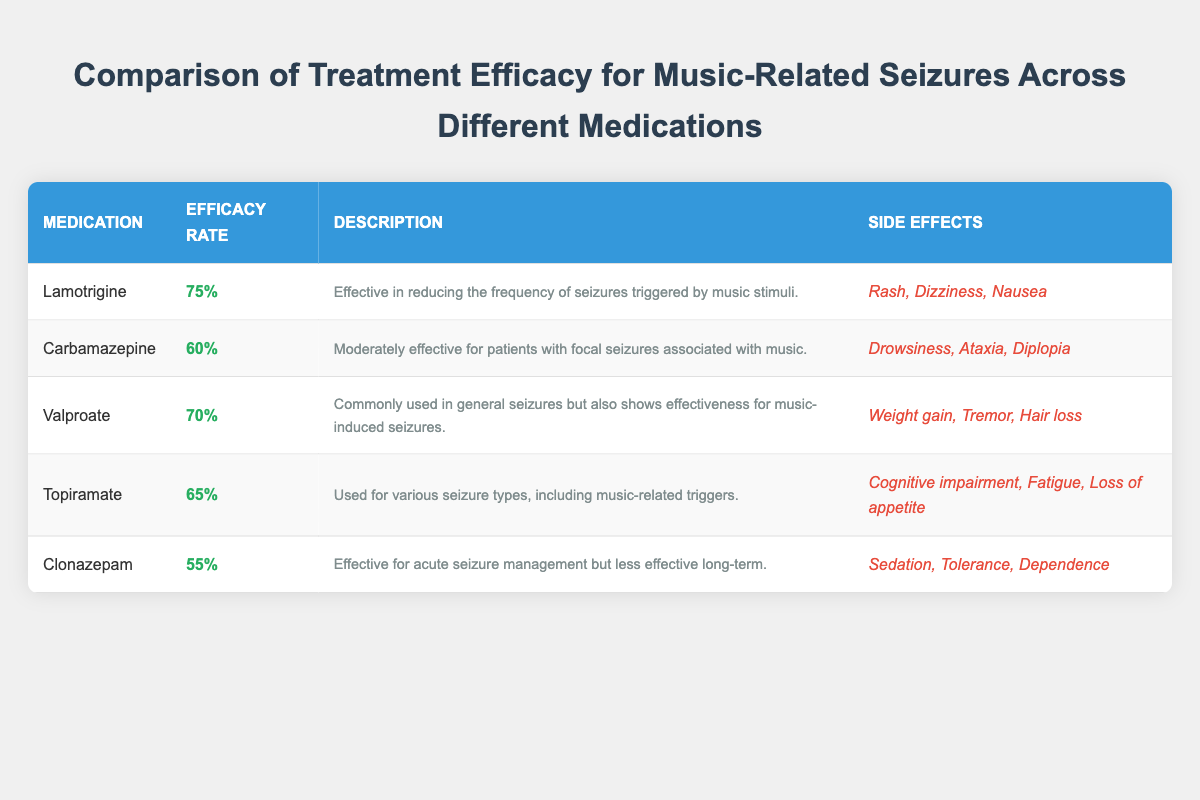What is the efficacy rate of Lamotrigine? The table states that the efficacy rate for Lamotrigine is 75%.
Answer: 75% Which medication has the lowest efficacy rate? By comparing the efficacy rates listed, Clonazepam has the lowest efficacy rate at 55%.
Answer: Clonazepam Is Valproate effective for music-induced seizures? Yes, the table describes Valproate as commonly used in general seizures and effective for music-induced seizures.
Answer: Yes What is the average efficacy rate of the medications listed in the table? First, we sum the efficacy rates: 75 + 60 + 70 + 65 + 55 = 325. There are 5 medications, so we divide: 325 / 5 = 65.
Answer: 65 Does Topiramate have a higher efficacy rate than Clonazepam? Topiramate has an efficacy rate of 65%, while Clonazepam has 55%. Since 65 is greater than 55, Topiramate does have a higher rate.
Answer: Yes What side effects are associated with Carbamazepine? The table lists Drowsiness, Ataxia, and Diplopia as the side effects associated with Carbamazepine.
Answer: Drowsiness, Ataxia, Diplopia Which medication is described as effective in reducing the frequency of seizures triggered by music stimuli? The description for Lamotrigine states it is effective in reducing the frequency of seizures triggered by music stimuli.
Answer: Lamotrigine What is the difference between the highest and lowest efficacy rates? The highest efficacy rate is 75% for Lamotrigine, and the lowest is 55% for Clonazepam. The difference is 75 - 55 = 20.
Answer: 20 Is the side effect profile for Lamotrigine more favorable than that of Clonazepam? Lamotrigine has side effects of Rash, Dizziness, and Nausea while Clonazepam's side effects include Sedation, Tolerance, and Dependence. In general terms, Lamotrigine's side effects may be viewed as less severe.
Answer: Yes 